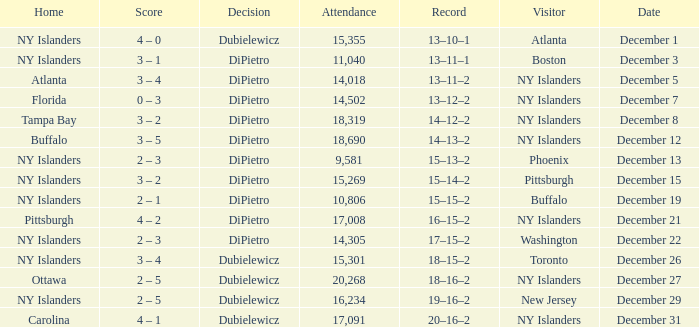Name the date for attendance more than 20,268 None. 